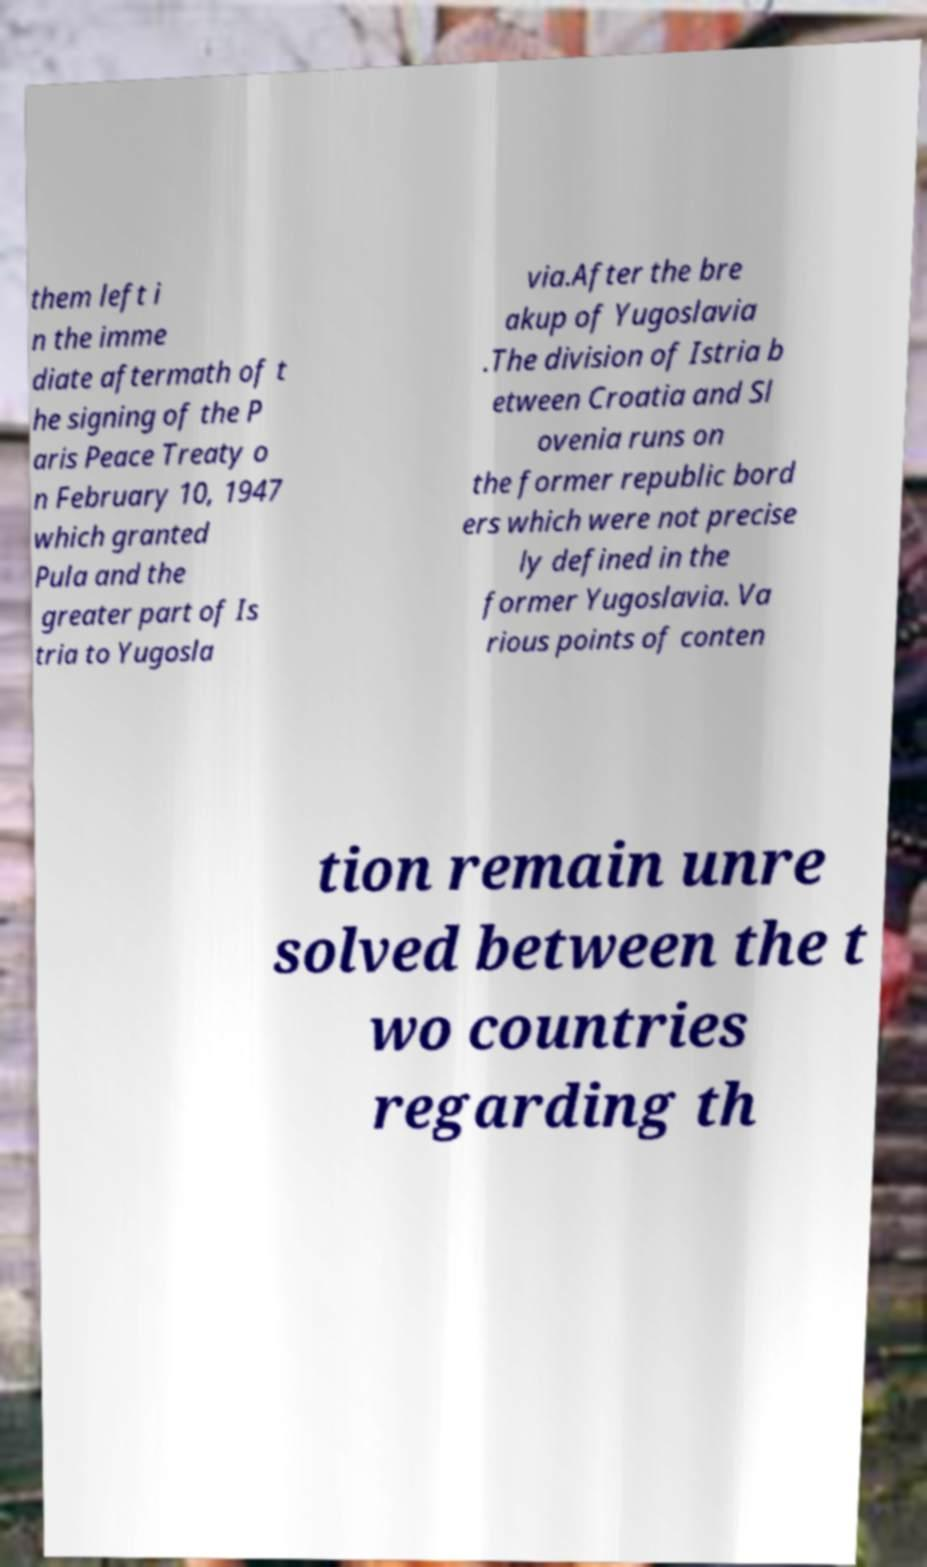Can you accurately transcribe the text from the provided image for me? them left i n the imme diate aftermath of t he signing of the P aris Peace Treaty o n February 10, 1947 which granted Pula and the greater part of Is tria to Yugosla via.After the bre akup of Yugoslavia .The division of Istria b etween Croatia and Sl ovenia runs on the former republic bord ers which were not precise ly defined in the former Yugoslavia. Va rious points of conten tion remain unre solved between the t wo countries regarding th 